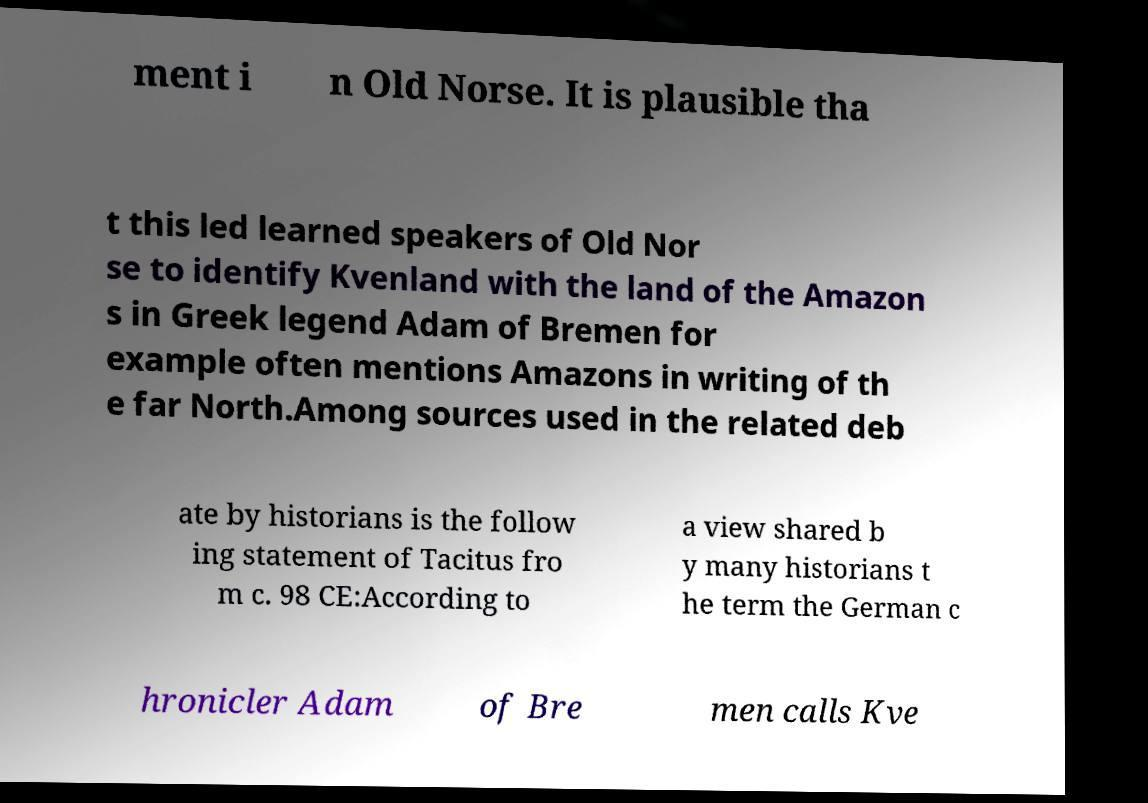For documentation purposes, I need the text within this image transcribed. Could you provide that? ment i n Old Norse. It is plausible tha t this led learned speakers of Old Nor se to identify Kvenland with the land of the Amazon s in Greek legend Adam of Bremen for example often mentions Amazons in writing of th e far North.Among sources used in the related deb ate by historians is the follow ing statement of Tacitus fro m c. 98 CE:According to a view shared b y many historians t he term the German c hronicler Adam of Bre men calls Kve 